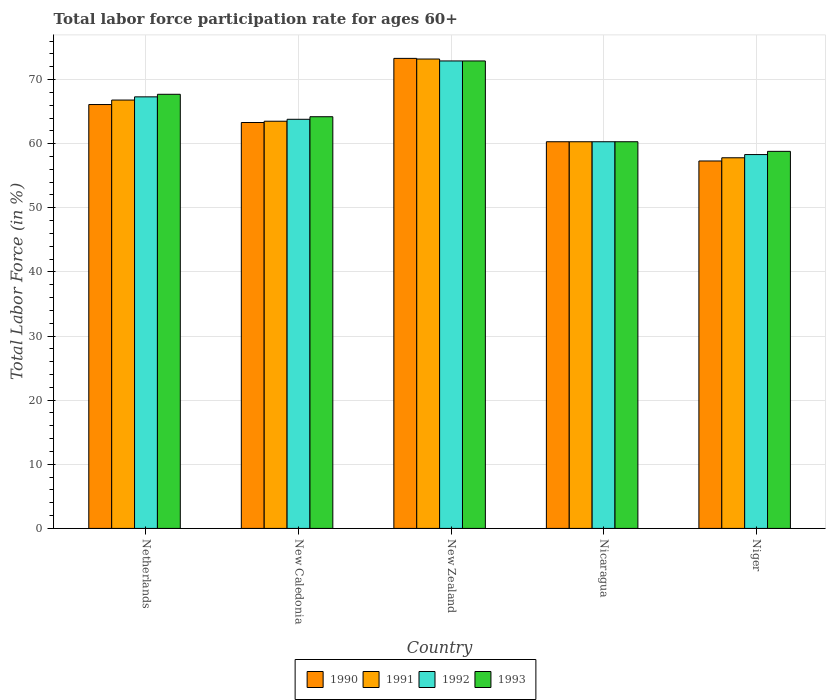How many different coloured bars are there?
Offer a terse response. 4. Are the number of bars per tick equal to the number of legend labels?
Provide a succinct answer. Yes. Are the number of bars on each tick of the X-axis equal?
Provide a succinct answer. Yes. What is the label of the 3rd group of bars from the left?
Provide a succinct answer. New Zealand. In how many cases, is the number of bars for a given country not equal to the number of legend labels?
Your answer should be very brief. 0. What is the labor force participation rate in 1993 in Nicaragua?
Your answer should be compact. 60.3. Across all countries, what is the maximum labor force participation rate in 1991?
Make the answer very short. 73.2. Across all countries, what is the minimum labor force participation rate in 1992?
Offer a terse response. 58.3. In which country was the labor force participation rate in 1993 maximum?
Make the answer very short. New Zealand. In which country was the labor force participation rate in 1992 minimum?
Your answer should be compact. Niger. What is the total labor force participation rate in 1992 in the graph?
Give a very brief answer. 322.6. What is the difference between the labor force participation rate in 1991 in New Caledonia and that in Nicaragua?
Keep it short and to the point. 3.2. What is the difference between the labor force participation rate in 1991 in New Zealand and the labor force participation rate in 1993 in Nicaragua?
Ensure brevity in your answer.  12.9. What is the average labor force participation rate in 1991 per country?
Your answer should be very brief. 64.32. What is the difference between the labor force participation rate of/in 1991 and labor force participation rate of/in 1993 in Niger?
Your answer should be compact. -1. In how many countries, is the labor force participation rate in 1992 greater than 12 %?
Provide a short and direct response. 5. What is the ratio of the labor force participation rate in 1991 in New Zealand to that in Nicaragua?
Ensure brevity in your answer.  1.21. What is the difference between the highest and the second highest labor force participation rate in 1991?
Give a very brief answer. 6.4. What is the difference between the highest and the lowest labor force participation rate in 1991?
Your response must be concise. 15.4. Is the sum of the labor force participation rate in 1992 in Netherlands and Nicaragua greater than the maximum labor force participation rate in 1990 across all countries?
Offer a terse response. Yes. Is it the case that in every country, the sum of the labor force participation rate in 1992 and labor force participation rate in 1993 is greater than the sum of labor force participation rate in 1990 and labor force participation rate in 1991?
Make the answer very short. No. What does the 3rd bar from the right in Niger represents?
Your response must be concise. 1991. Is it the case that in every country, the sum of the labor force participation rate in 1991 and labor force participation rate in 1992 is greater than the labor force participation rate in 1993?
Offer a very short reply. Yes. How many countries are there in the graph?
Offer a terse response. 5. What is the difference between two consecutive major ticks on the Y-axis?
Offer a terse response. 10. Where does the legend appear in the graph?
Ensure brevity in your answer.  Bottom center. What is the title of the graph?
Make the answer very short. Total labor force participation rate for ages 60+. What is the label or title of the X-axis?
Your answer should be very brief. Country. What is the label or title of the Y-axis?
Your response must be concise. Total Labor Force (in %). What is the Total Labor Force (in %) of 1990 in Netherlands?
Keep it short and to the point. 66.1. What is the Total Labor Force (in %) in 1991 in Netherlands?
Make the answer very short. 66.8. What is the Total Labor Force (in %) in 1992 in Netherlands?
Your answer should be very brief. 67.3. What is the Total Labor Force (in %) in 1993 in Netherlands?
Your answer should be very brief. 67.7. What is the Total Labor Force (in %) in 1990 in New Caledonia?
Offer a very short reply. 63.3. What is the Total Labor Force (in %) in 1991 in New Caledonia?
Ensure brevity in your answer.  63.5. What is the Total Labor Force (in %) in 1992 in New Caledonia?
Keep it short and to the point. 63.8. What is the Total Labor Force (in %) in 1993 in New Caledonia?
Offer a very short reply. 64.2. What is the Total Labor Force (in %) of 1990 in New Zealand?
Ensure brevity in your answer.  73.3. What is the Total Labor Force (in %) of 1991 in New Zealand?
Give a very brief answer. 73.2. What is the Total Labor Force (in %) of 1992 in New Zealand?
Your answer should be compact. 72.9. What is the Total Labor Force (in %) of 1993 in New Zealand?
Give a very brief answer. 72.9. What is the Total Labor Force (in %) in 1990 in Nicaragua?
Your answer should be very brief. 60.3. What is the Total Labor Force (in %) in 1991 in Nicaragua?
Your answer should be very brief. 60.3. What is the Total Labor Force (in %) of 1992 in Nicaragua?
Provide a succinct answer. 60.3. What is the Total Labor Force (in %) in 1993 in Nicaragua?
Give a very brief answer. 60.3. What is the Total Labor Force (in %) of 1990 in Niger?
Your answer should be compact. 57.3. What is the Total Labor Force (in %) of 1991 in Niger?
Keep it short and to the point. 57.8. What is the Total Labor Force (in %) of 1992 in Niger?
Ensure brevity in your answer.  58.3. What is the Total Labor Force (in %) of 1993 in Niger?
Provide a succinct answer. 58.8. Across all countries, what is the maximum Total Labor Force (in %) in 1990?
Provide a short and direct response. 73.3. Across all countries, what is the maximum Total Labor Force (in %) of 1991?
Keep it short and to the point. 73.2. Across all countries, what is the maximum Total Labor Force (in %) in 1992?
Your answer should be compact. 72.9. Across all countries, what is the maximum Total Labor Force (in %) of 1993?
Give a very brief answer. 72.9. Across all countries, what is the minimum Total Labor Force (in %) of 1990?
Give a very brief answer. 57.3. Across all countries, what is the minimum Total Labor Force (in %) in 1991?
Give a very brief answer. 57.8. Across all countries, what is the minimum Total Labor Force (in %) in 1992?
Make the answer very short. 58.3. Across all countries, what is the minimum Total Labor Force (in %) of 1993?
Offer a very short reply. 58.8. What is the total Total Labor Force (in %) in 1990 in the graph?
Your answer should be compact. 320.3. What is the total Total Labor Force (in %) of 1991 in the graph?
Keep it short and to the point. 321.6. What is the total Total Labor Force (in %) in 1992 in the graph?
Give a very brief answer. 322.6. What is the total Total Labor Force (in %) in 1993 in the graph?
Your answer should be compact. 323.9. What is the difference between the Total Labor Force (in %) in 1992 in Netherlands and that in New Caledonia?
Make the answer very short. 3.5. What is the difference between the Total Labor Force (in %) in 1993 in Netherlands and that in New Caledonia?
Offer a terse response. 3.5. What is the difference between the Total Labor Force (in %) in 1991 in Netherlands and that in New Zealand?
Your answer should be compact. -6.4. What is the difference between the Total Labor Force (in %) of 1992 in Netherlands and that in New Zealand?
Ensure brevity in your answer.  -5.6. What is the difference between the Total Labor Force (in %) of 1993 in Netherlands and that in New Zealand?
Your response must be concise. -5.2. What is the difference between the Total Labor Force (in %) of 1991 in Netherlands and that in Nicaragua?
Offer a very short reply. 6.5. What is the difference between the Total Labor Force (in %) in 1993 in Netherlands and that in Nicaragua?
Your answer should be very brief. 7.4. What is the difference between the Total Labor Force (in %) in 1990 in Netherlands and that in Niger?
Offer a very short reply. 8.8. What is the difference between the Total Labor Force (in %) of 1991 in Netherlands and that in Niger?
Provide a short and direct response. 9. What is the difference between the Total Labor Force (in %) in 1991 in New Caledonia and that in New Zealand?
Provide a succinct answer. -9.7. What is the difference between the Total Labor Force (in %) of 1990 in New Caledonia and that in Nicaragua?
Provide a short and direct response. 3. What is the difference between the Total Labor Force (in %) of 1991 in New Caledonia and that in Nicaragua?
Your answer should be very brief. 3.2. What is the difference between the Total Labor Force (in %) of 1990 in New Caledonia and that in Niger?
Ensure brevity in your answer.  6. What is the difference between the Total Labor Force (in %) of 1991 in New Zealand and that in Nicaragua?
Keep it short and to the point. 12.9. What is the difference between the Total Labor Force (in %) in 1992 in New Zealand and that in Niger?
Ensure brevity in your answer.  14.6. What is the difference between the Total Labor Force (in %) in 1990 in Nicaragua and that in Niger?
Your response must be concise. 3. What is the difference between the Total Labor Force (in %) in 1991 in Nicaragua and that in Niger?
Your answer should be very brief. 2.5. What is the difference between the Total Labor Force (in %) of 1990 in Netherlands and the Total Labor Force (in %) of 1991 in New Caledonia?
Offer a very short reply. 2.6. What is the difference between the Total Labor Force (in %) in 1990 in Netherlands and the Total Labor Force (in %) in 1992 in New Caledonia?
Provide a short and direct response. 2.3. What is the difference between the Total Labor Force (in %) in 1992 in Netherlands and the Total Labor Force (in %) in 1993 in New Caledonia?
Offer a terse response. 3.1. What is the difference between the Total Labor Force (in %) of 1992 in Netherlands and the Total Labor Force (in %) of 1993 in New Zealand?
Give a very brief answer. -5.6. What is the difference between the Total Labor Force (in %) in 1990 in Netherlands and the Total Labor Force (in %) in 1991 in Nicaragua?
Keep it short and to the point. 5.8. What is the difference between the Total Labor Force (in %) in 1990 in Netherlands and the Total Labor Force (in %) in 1992 in Nicaragua?
Provide a succinct answer. 5.8. What is the difference between the Total Labor Force (in %) of 1990 in Netherlands and the Total Labor Force (in %) of 1991 in Niger?
Your answer should be very brief. 8.3. What is the difference between the Total Labor Force (in %) in 1990 in Netherlands and the Total Labor Force (in %) in 1992 in Niger?
Your answer should be compact. 7.8. What is the difference between the Total Labor Force (in %) of 1991 in Netherlands and the Total Labor Force (in %) of 1992 in Niger?
Ensure brevity in your answer.  8.5. What is the difference between the Total Labor Force (in %) in 1990 in New Caledonia and the Total Labor Force (in %) in 1991 in New Zealand?
Offer a very short reply. -9.9. What is the difference between the Total Labor Force (in %) of 1992 in New Caledonia and the Total Labor Force (in %) of 1993 in New Zealand?
Provide a short and direct response. -9.1. What is the difference between the Total Labor Force (in %) of 1990 in New Caledonia and the Total Labor Force (in %) of 1991 in Nicaragua?
Offer a very short reply. 3. What is the difference between the Total Labor Force (in %) in 1992 in New Caledonia and the Total Labor Force (in %) in 1993 in Nicaragua?
Give a very brief answer. 3.5. What is the difference between the Total Labor Force (in %) of 1991 in New Caledonia and the Total Labor Force (in %) of 1992 in Niger?
Offer a very short reply. 5.2. What is the difference between the Total Labor Force (in %) in 1990 in New Zealand and the Total Labor Force (in %) in 1991 in Nicaragua?
Give a very brief answer. 13. What is the difference between the Total Labor Force (in %) of 1990 in New Zealand and the Total Labor Force (in %) of 1993 in Nicaragua?
Provide a short and direct response. 13. What is the difference between the Total Labor Force (in %) of 1991 in New Zealand and the Total Labor Force (in %) of 1993 in Nicaragua?
Offer a very short reply. 12.9. What is the difference between the Total Labor Force (in %) of 1992 in New Zealand and the Total Labor Force (in %) of 1993 in Nicaragua?
Your response must be concise. 12.6. What is the difference between the Total Labor Force (in %) of 1990 in New Zealand and the Total Labor Force (in %) of 1993 in Niger?
Provide a succinct answer. 14.5. What is the difference between the Total Labor Force (in %) in 1991 in New Zealand and the Total Labor Force (in %) in 1992 in Niger?
Your response must be concise. 14.9. What is the difference between the Total Labor Force (in %) in 1992 in New Zealand and the Total Labor Force (in %) in 1993 in Niger?
Provide a short and direct response. 14.1. What is the difference between the Total Labor Force (in %) of 1990 in Nicaragua and the Total Labor Force (in %) of 1992 in Niger?
Make the answer very short. 2. What is the difference between the Total Labor Force (in %) in 1992 in Nicaragua and the Total Labor Force (in %) in 1993 in Niger?
Ensure brevity in your answer.  1.5. What is the average Total Labor Force (in %) in 1990 per country?
Offer a very short reply. 64.06. What is the average Total Labor Force (in %) in 1991 per country?
Make the answer very short. 64.32. What is the average Total Labor Force (in %) of 1992 per country?
Your answer should be very brief. 64.52. What is the average Total Labor Force (in %) of 1993 per country?
Make the answer very short. 64.78. What is the difference between the Total Labor Force (in %) of 1990 and Total Labor Force (in %) of 1993 in Netherlands?
Offer a terse response. -1.6. What is the difference between the Total Labor Force (in %) of 1991 and Total Labor Force (in %) of 1992 in Netherlands?
Offer a very short reply. -0.5. What is the difference between the Total Labor Force (in %) of 1991 and Total Labor Force (in %) of 1993 in Netherlands?
Make the answer very short. -0.9. What is the difference between the Total Labor Force (in %) in 1992 and Total Labor Force (in %) in 1993 in Netherlands?
Make the answer very short. -0.4. What is the difference between the Total Labor Force (in %) in 1990 and Total Labor Force (in %) in 1991 in New Caledonia?
Ensure brevity in your answer.  -0.2. What is the difference between the Total Labor Force (in %) of 1991 and Total Labor Force (in %) of 1992 in New Caledonia?
Provide a short and direct response. -0.3. What is the difference between the Total Labor Force (in %) in 1990 and Total Labor Force (in %) in 1991 in New Zealand?
Keep it short and to the point. 0.1. What is the difference between the Total Labor Force (in %) in 1990 and Total Labor Force (in %) in 1993 in New Zealand?
Provide a short and direct response. 0.4. What is the difference between the Total Labor Force (in %) in 1992 and Total Labor Force (in %) in 1993 in New Zealand?
Make the answer very short. 0. What is the difference between the Total Labor Force (in %) of 1990 and Total Labor Force (in %) of 1991 in Nicaragua?
Offer a very short reply. 0. What is the difference between the Total Labor Force (in %) of 1990 and Total Labor Force (in %) of 1993 in Nicaragua?
Your answer should be very brief. 0. What is the difference between the Total Labor Force (in %) of 1991 and Total Labor Force (in %) of 1992 in Nicaragua?
Your answer should be compact. 0. What is the difference between the Total Labor Force (in %) of 1991 and Total Labor Force (in %) of 1993 in Nicaragua?
Provide a short and direct response. 0. What is the difference between the Total Labor Force (in %) in 1992 and Total Labor Force (in %) in 1993 in Nicaragua?
Make the answer very short. 0. What is the difference between the Total Labor Force (in %) of 1991 and Total Labor Force (in %) of 1992 in Niger?
Your answer should be compact. -0.5. What is the difference between the Total Labor Force (in %) in 1991 and Total Labor Force (in %) in 1993 in Niger?
Provide a succinct answer. -1. What is the ratio of the Total Labor Force (in %) in 1990 in Netherlands to that in New Caledonia?
Your answer should be very brief. 1.04. What is the ratio of the Total Labor Force (in %) of 1991 in Netherlands to that in New Caledonia?
Keep it short and to the point. 1.05. What is the ratio of the Total Labor Force (in %) in 1992 in Netherlands to that in New Caledonia?
Keep it short and to the point. 1.05. What is the ratio of the Total Labor Force (in %) in 1993 in Netherlands to that in New Caledonia?
Give a very brief answer. 1.05. What is the ratio of the Total Labor Force (in %) in 1990 in Netherlands to that in New Zealand?
Provide a short and direct response. 0.9. What is the ratio of the Total Labor Force (in %) in 1991 in Netherlands to that in New Zealand?
Keep it short and to the point. 0.91. What is the ratio of the Total Labor Force (in %) in 1992 in Netherlands to that in New Zealand?
Your response must be concise. 0.92. What is the ratio of the Total Labor Force (in %) of 1993 in Netherlands to that in New Zealand?
Offer a very short reply. 0.93. What is the ratio of the Total Labor Force (in %) of 1990 in Netherlands to that in Nicaragua?
Your answer should be compact. 1.1. What is the ratio of the Total Labor Force (in %) of 1991 in Netherlands to that in Nicaragua?
Give a very brief answer. 1.11. What is the ratio of the Total Labor Force (in %) in 1992 in Netherlands to that in Nicaragua?
Keep it short and to the point. 1.12. What is the ratio of the Total Labor Force (in %) in 1993 in Netherlands to that in Nicaragua?
Make the answer very short. 1.12. What is the ratio of the Total Labor Force (in %) of 1990 in Netherlands to that in Niger?
Offer a very short reply. 1.15. What is the ratio of the Total Labor Force (in %) of 1991 in Netherlands to that in Niger?
Offer a terse response. 1.16. What is the ratio of the Total Labor Force (in %) of 1992 in Netherlands to that in Niger?
Offer a terse response. 1.15. What is the ratio of the Total Labor Force (in %) of 1993 in Netherlands to that in Niger?
Your response must be concise. 1.15. What is the ratio of the Total Labor Force (in %) in 1990 in New Caledonia to that in New Zealand?
Offer a terse response. 0.86. What is the ratio of the Total Labor Force (in %) of 1991 in New Caledonia to that in New Zealand?
Your answer should be very brief. 0.87. What is the ratio of the Total Labor Force (in %) of 1992 in New Caledonia to that in New Zealand?
Make the answer very short. 0.88. What is the ratio of the Total Labor Force (in %) of 1993 in New Caledonia to that in New Zealand?
Provide a short and direct response. 0.88. What is the ratio of the Total Labor Force (in %) of 1990 in New Caledonia to that in Nicaragua?
Your response must be concise. 1.05. What is the ratio of the Total Labor Force (in %) in 1991 in New Caledonia to that in Nicaragua?
Your response must be concise. 1.05. What is the ratio of the Total Labor Force (in %) in 1992 in New Caledonia to that in Nicaragua?
Give a very brief answer. 1.06. What is the ratio of the Total Labor Force (in %) of 1993 in New Caledonia to that in Nicaragua?
Your answer should be compact. 1.06. What is the ratio of the Total Labor Force (in %) of 1990 in New Caledonia to that in Niger?
Your response must be concise. 1.1. What is the ratio of the Total Labor Force (in %) in 1991 in New Caledonia to that in Niger?
Offer a terse response. 1.1. What is the ratio of the Total Labor Force (in %) in 1992 in New Caledonia to that in Niger?
Your answer should be compact. 1.09. What is the ratio of the Total Labor Force (in %) in 1993 in New Caledonia to that in Niger?
Provide a short and direct response. 1.09. What is the ratio of the Total Labor Force (in %) of 1990 in New Zealand to that in Nicaragua?
Make the answer very short. 1.22. What is the ratio of the Total Labor Force (in %) of 1991 in New Zealand to that in Nicaragua?
Your answer should be compact. 1.21. What is the ratio of the Total Labor Force (in %) in 1992 in New Zealand to that in Nicaragua?
Provide a short and direct response. 1.21. What is the ratio of the Total Labor Force (in %) in 1993 in New Zealand to that in Nicaragua?
Make the answer very short. 1.21. What is the ratio of the Total Labor Force (in %) in 1990 in New Zealand to that in Niger?
Your answer should be compact. 1.28. What is the ratio of the Total Labor Force (in %) of 1991 in New Zealand to that in Niger?
Provide a short and direct response. 1.27. What is the ratio of the Total Labor Force (in %) of 1992 in New Zealand to that in Niger?
Your response must be concise. 1.25. What is the ratio of the Total Labor Force (in %) of 1993 in New Zealand to that in Niger?
Ensure brevity in your answer.  1.24. What is the ratio of the Total Labor Force (in %) of 1990 in Nicaragua to that in Niger?
Your response must be concise. 1.05. What is the ratio of the Total Labor Force (in %) in 1991 in Nicaragua to that in Niger?
Make the answer very short. 1.04. What is the ratio of the Total Labor Force (in %) in 1992 in Nicaragua to that in Niger?
Keep it short and to the point. 1.03. What is the ratio of the Total Labor Force (in %) in 1993 in Nicaragua to that in Niger?
Make the answer very short. 1.03. What is the difference between the highest and the second highest Total Labor Force (in %) in 1990?
Give a very brief answer. 7.2. What is the difference between the highest and the second highest Total Labor Force (in %) of 1992?
Your answer should be compact. 5.6. What is the difference between the highest and the lowest Total Labor Force (in %) of 1993?
Make the answer very short. 14.1. 